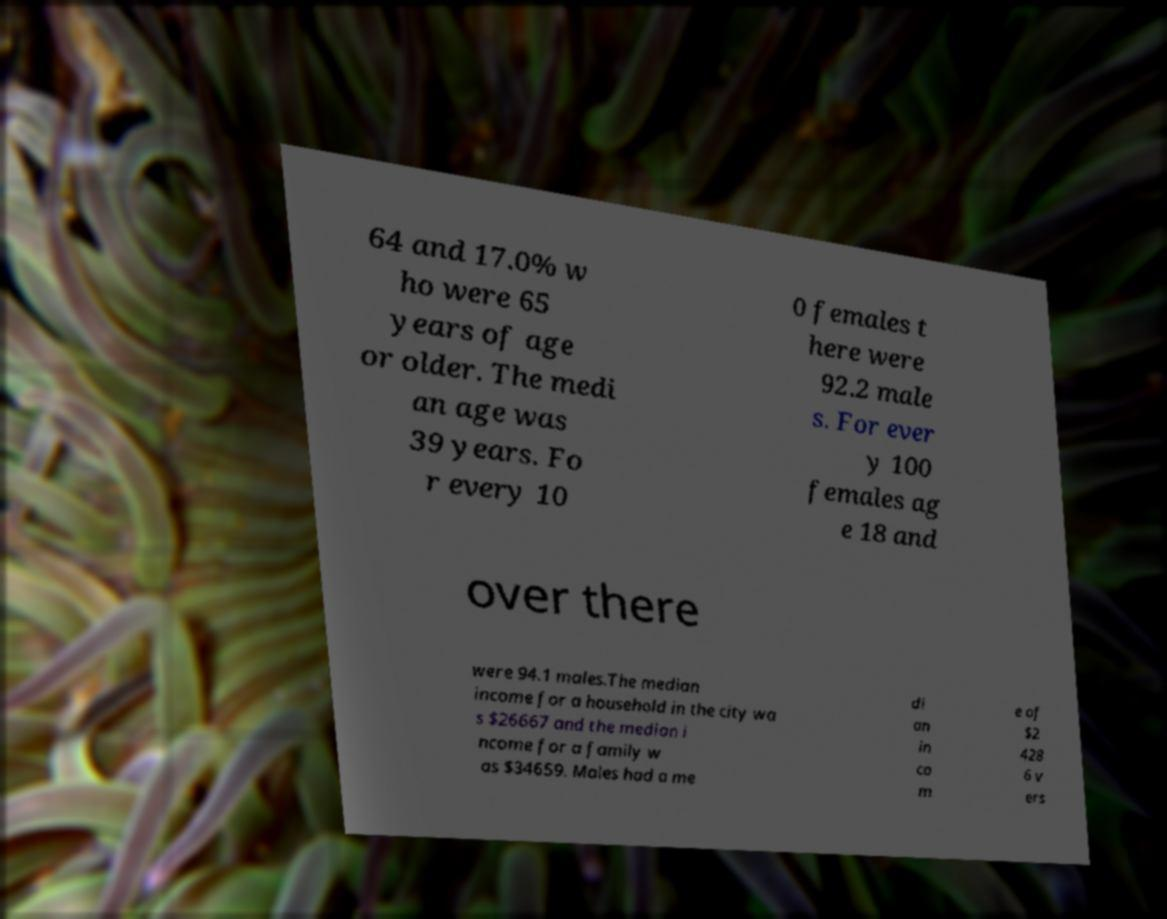I need the written content from this picture converted into text. Can you do that? 64 and 17.0% w ho were 65 years of age or older. The medi an age was 39 years. Fo r every 10 0 females t here were 92.2 male s. For ever y 100 females ag e 18 and over there were 94.1 males.The median income for a household in the city wa s $26667 and the median i ncome for a family w as $34659. Males had a me di an in co m e of $2 428 6 v ers 